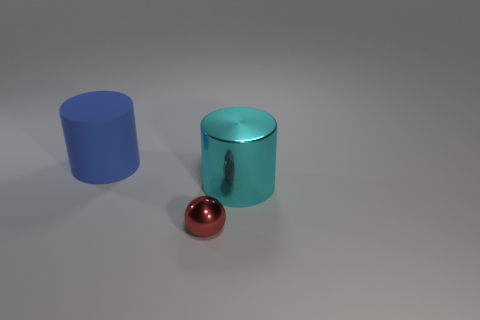Is there any other thing that has the same size as the shiny sphere?
Make the answer very short. No. Are there the same number of shiny cylinders that are left of the tiny shiny sphere and tiny gray metal cubes?
Make the answer very short. Yes. What shape is the cyan object that is the same size as the blue cylinder?
Your response must be concise. Cylinder. What is the small thing made of?
Your answer should be compact. Metal. There is a thing that is behind the tiny red ball and on the left side of the large shiny thing; what is its color?
Keep it short and to the point. Blue. Are there the same number of big blue things that are on the left side of the big blue cylinder and small balls that are on the right side of the large cyan metallic cylinder?
Ensure brevity in your answer.  Yes. There is a large cylinder that is made of the same material as the tiny ball; what color is it?
Your response must be concise. Cyan. There is a large thing on the right side of the thing left of the tiny metal sphere; is there a rubber object left of it?
Your answer should be very brief. Yes. There is a large cyan object that is made of the same material as the small thing; what is its shape?
Offer a terse response. Cylinder. Is there anything else that has the same shape as the small thing?
Make the answer very short. No. 